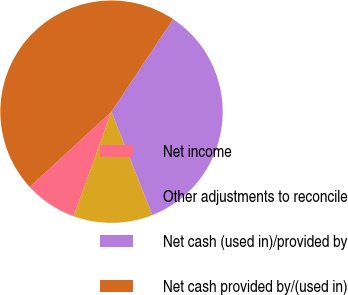Convert chart to OTSL. <chart><loc_0><loc_0><loc_500><loc_500><pie_chart><fcel>Net income<fcel>Other adjustments to reconcile<fcel>Net cash (used in)/provided by<fcel>Net cash provided by/(used in)<nl><fcel>7.64%<fcel>11.5%<fcel>34.67%<fcel>46.19%<nl></chart> 